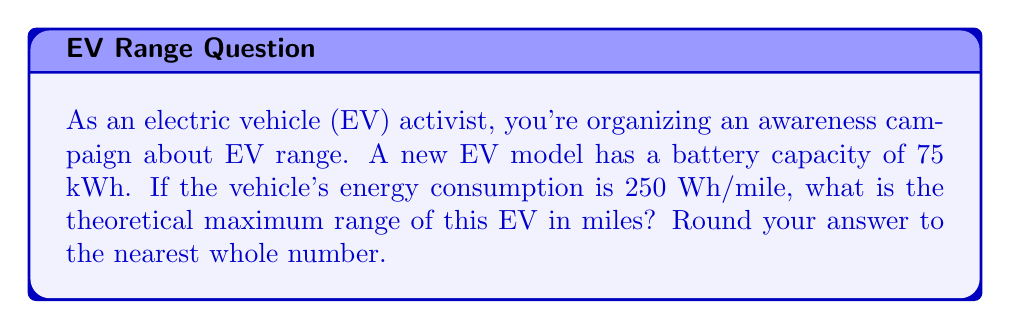Show me your answer to this math problem. To solve this problem, we need to use the relationship between energy capacity, energy consumption, and range. Let's break it down step-by-step:

1. Given information:
   - Battery capacity = 75 kWh
   - Energy consumption = 250 Wh/mile

2. Convert battery capacity to Wh:
   $75 \text{ kWh} = 75 \times 1000 \text{ Wh} = 75000 \text{ Wh}$

3. Set up the equation:
   $\text{Range (miles)} = \frac{\text{Battery Capacity (Wh)}}{\text{Energy Consumption (Wh/mile)}}$

4. Plug in the values:
   $\text{Range} = \frac{75000 \text{ Wh}}{250 \text{ Wh/mile}}$

5. Perform the division:
   $\text{Range} = 300 \text{ miles}$

6. Round to the nearest whole number:
   The range is already a whole number, so no rounding is necessary.

Therefore, the theoretical maximum range of this EV model is 300 miles.
Answer: 300 miles 